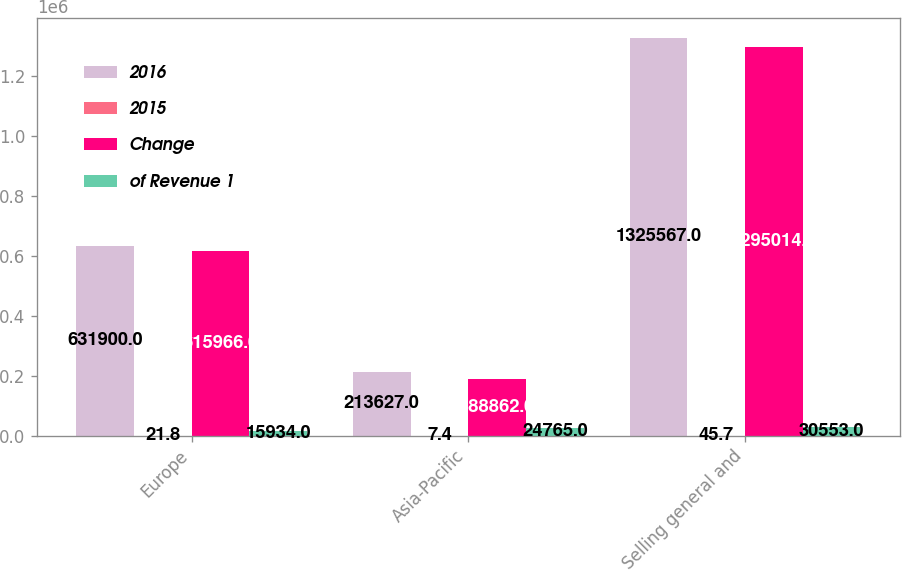Convert chart to OTSL. <chart><loc_0><loc_0><loc_500><loc_500><stacked_bar_chart><ecel><fcel>Europe<fcel>Asia-Pacific<fcel>Selling general and<nl><fcel>2016<fcel>631900<fcel>213627<fcel>1.32557e+06<nl><fcel>2015<fcel>21.8<fcel>7.4<fcel>45.7<nl><fcel>Change<fcel>615966<fcel>188862<fcel>1.29501e+06<nl><fcel>of Revenue 1<fcel>15934<fcel>24765<fcel>30553<nl></chart> 